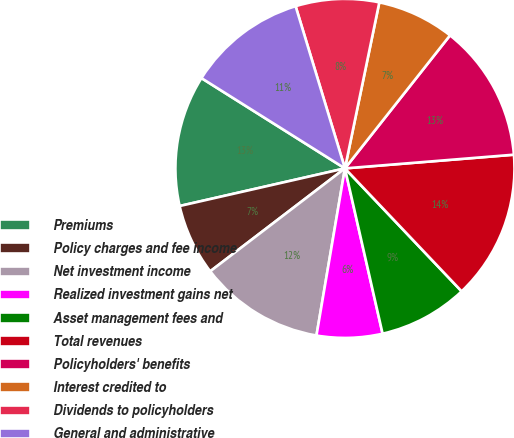<chart> <loc_0><loc_0><loc_500><loc_500><pie_chart><fcel>Premiums<fcel>Policy charges and fee income<fcel>Net investment income<fcel>Realized investment gains net<fcel>Asset management fees and<fcel>Total revenues<fcel>Policyholders' benefits<fcel>Interest credited to<fcel>Dividends to policyholders<fcel>General and administrative<nl><fcel>12.5%<fcel>6.82%<fcel>11.93%<fcel>6.25%<fcel>8.52%<fcel>14.2%<fcel>13.07%<fcel>7.39%<fcel>7.95%<fcel>11.36%<nl></chart> 